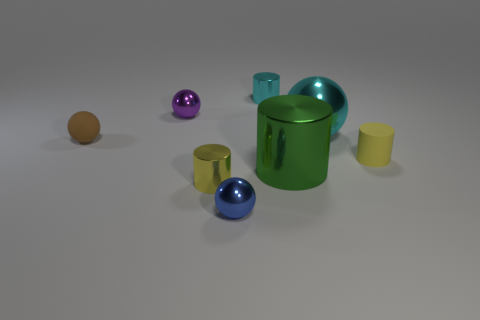Are there any small balls on the left side of the purple metallic thing on the left side of the yellow matte thing?
Make the answer very short. Yes. There is a thing that is both in front of the small cyan metal cylinder and behind the cyan metallic sphere; what color is it?
Offer a very short reply. Purple. How big is the cyan metal cylinder?
Your answer should be compact. Small. What number of cyan metallic cylinders are the same size as the blue metallic ball?
Offer a terse response. 1. Do the object to the left of the small purple ball and the cylinder behind the purple object have the same material?
Your response must be concise. No. What is the tiny sphere that is behind the tiny matte thing on the left side of the purple thing made of?
Your answer should be compact. Metal. There is a tiny yellow cylinder left of the small blue metal ball; what is it made of?
Give a very brief answer. Metal. How many tiny brown rubber things have the same shape as the green thing?
Keep it short and to the point. 0. Do the large ball and the rubber sphere have the same color?
Ensure brevity in your answer.  No. What is the material of the tiny cylinder that is to the left of the metal cylinder that is behind the small rubber thing that is right of the purple shiny sphere?
Ensure brevity in your answer.  Metal. 